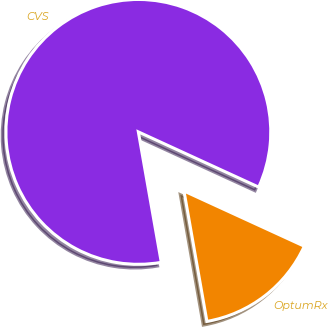Convert chart to OTSL. <chart><loc_0><loc_0><loc_500><loc_500><pie_chart><fcel>CVS<fcel>OptumRx<nl><fcel>84.62%<fcel>15.38%<nl></chart> 